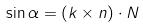Convert formula to latex. <formula><loc_0><loc_0><loc_500><loc_500>\sin \alpha = ( k \times n ) \cdot N</formula> 